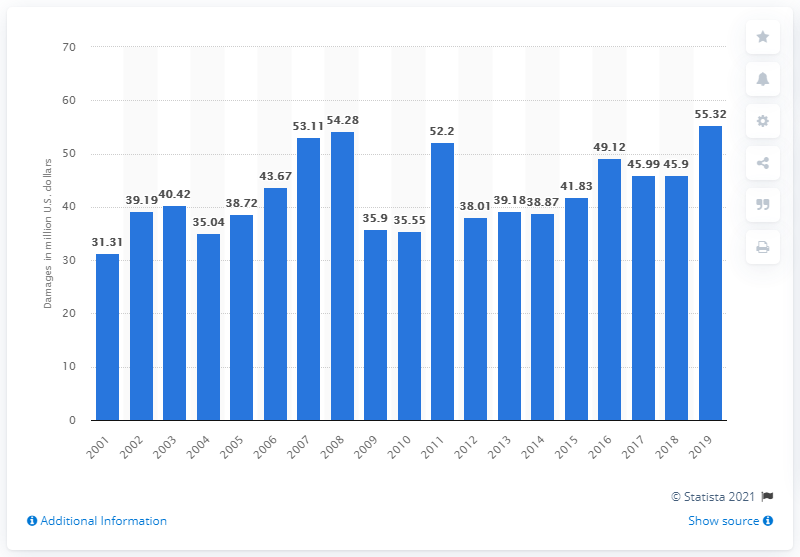Outline some significant characteristics in this image. In 2019, the total amount of damages caused by recreational boating accidents in the United States was $55.32 million. 